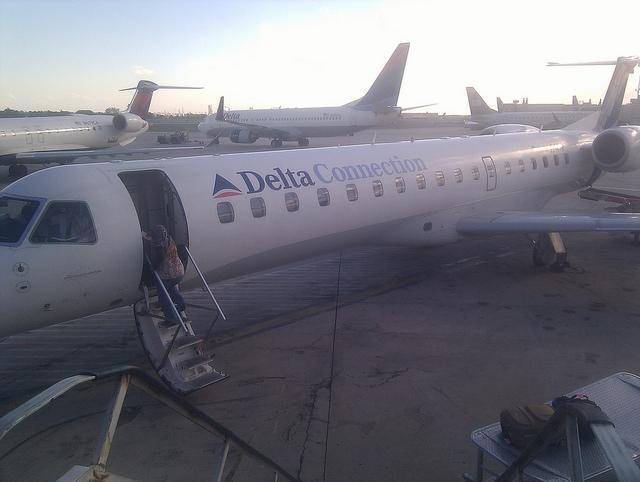How many airplanes are in the picture?
Give a very brief answer. 3. How many birds are in the air?
Give a very brief answer. 0. 